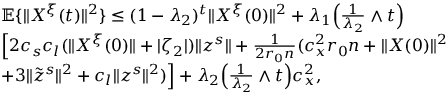Convert formula to latex. <formula><loc_0><loc_0><loc_500><loc_500>\begin{array} { r l } & { \mathbb { E } \{ \| X ^ { \xi } ( t ) \| ^ { 2 } \} \leq ( 1 - \lambda _ { 2 } ) ^ { t } \| X ^ { \xi } ( 0 ) \| ^ { 2 } + \lambda _ { 1 } \left ( \frac { 1 } { \lambda _ { 2 } } \wedge t \right ) } \\ & { \left [ 2 c _ { s } c _ { l } ( \| X ^ { \xi } ( 0 ) \| + | \zeta _ { 2 } | ) \| z ^ { s } \| + \frac { 1 } { 2 r _ { 0 } n } ( c _ { x } ^ { 2 } r _ { 0 } n + \| X ( 0 ) \| ^ { 2 } } \\ & { + 3 \| \tilde { z } ^ { s } \| ^ { 2 } + c _ { l } \| z ^ { s } \| ^ { 2 } ) \right ] + \lambda _ { 2 } \left ( \frac { 1 } { \lambda _ { 2 } } \wedge t \right ) c _ { x } ^ { 2 } , } \end{array}</formula> 